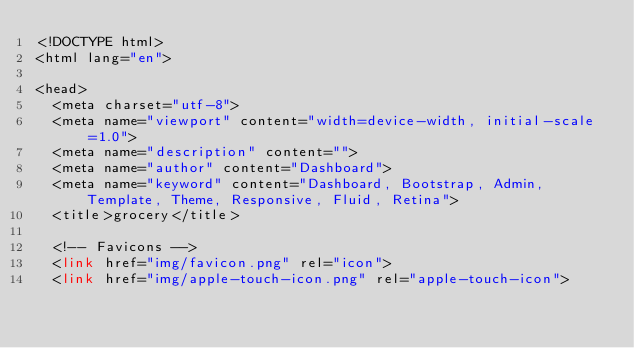Convert code to text. <code><loc_0><loc_0><loc_500><loc_500><_PHP_><!DOCTYPE html>
<html lang="en">

<head>
  <meta charset="utf-8">
  <meta name="viewport" content="width=device-width, initial-scale=1.0">
  <meta name="description" content="">
  <meta name="author" content="Dashboard">
  <meta name="keyword" content="Dashboard, Bootstrap, Admin, Template, Theme, Responsive, Fluid, Retina">
  <title>grocery</title>

  <!-- Favicons -->
  <link href="img/favicon.png" rel="icon">
  <link href="img/apple-touch-icon.png" rel="apple-touch-icon">
</code> 